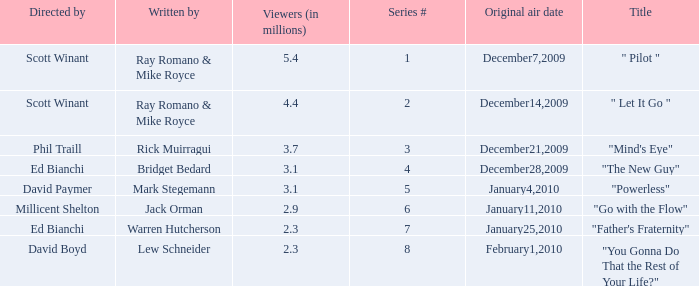How many episodes are written by Lew Schneider? 1.0. 